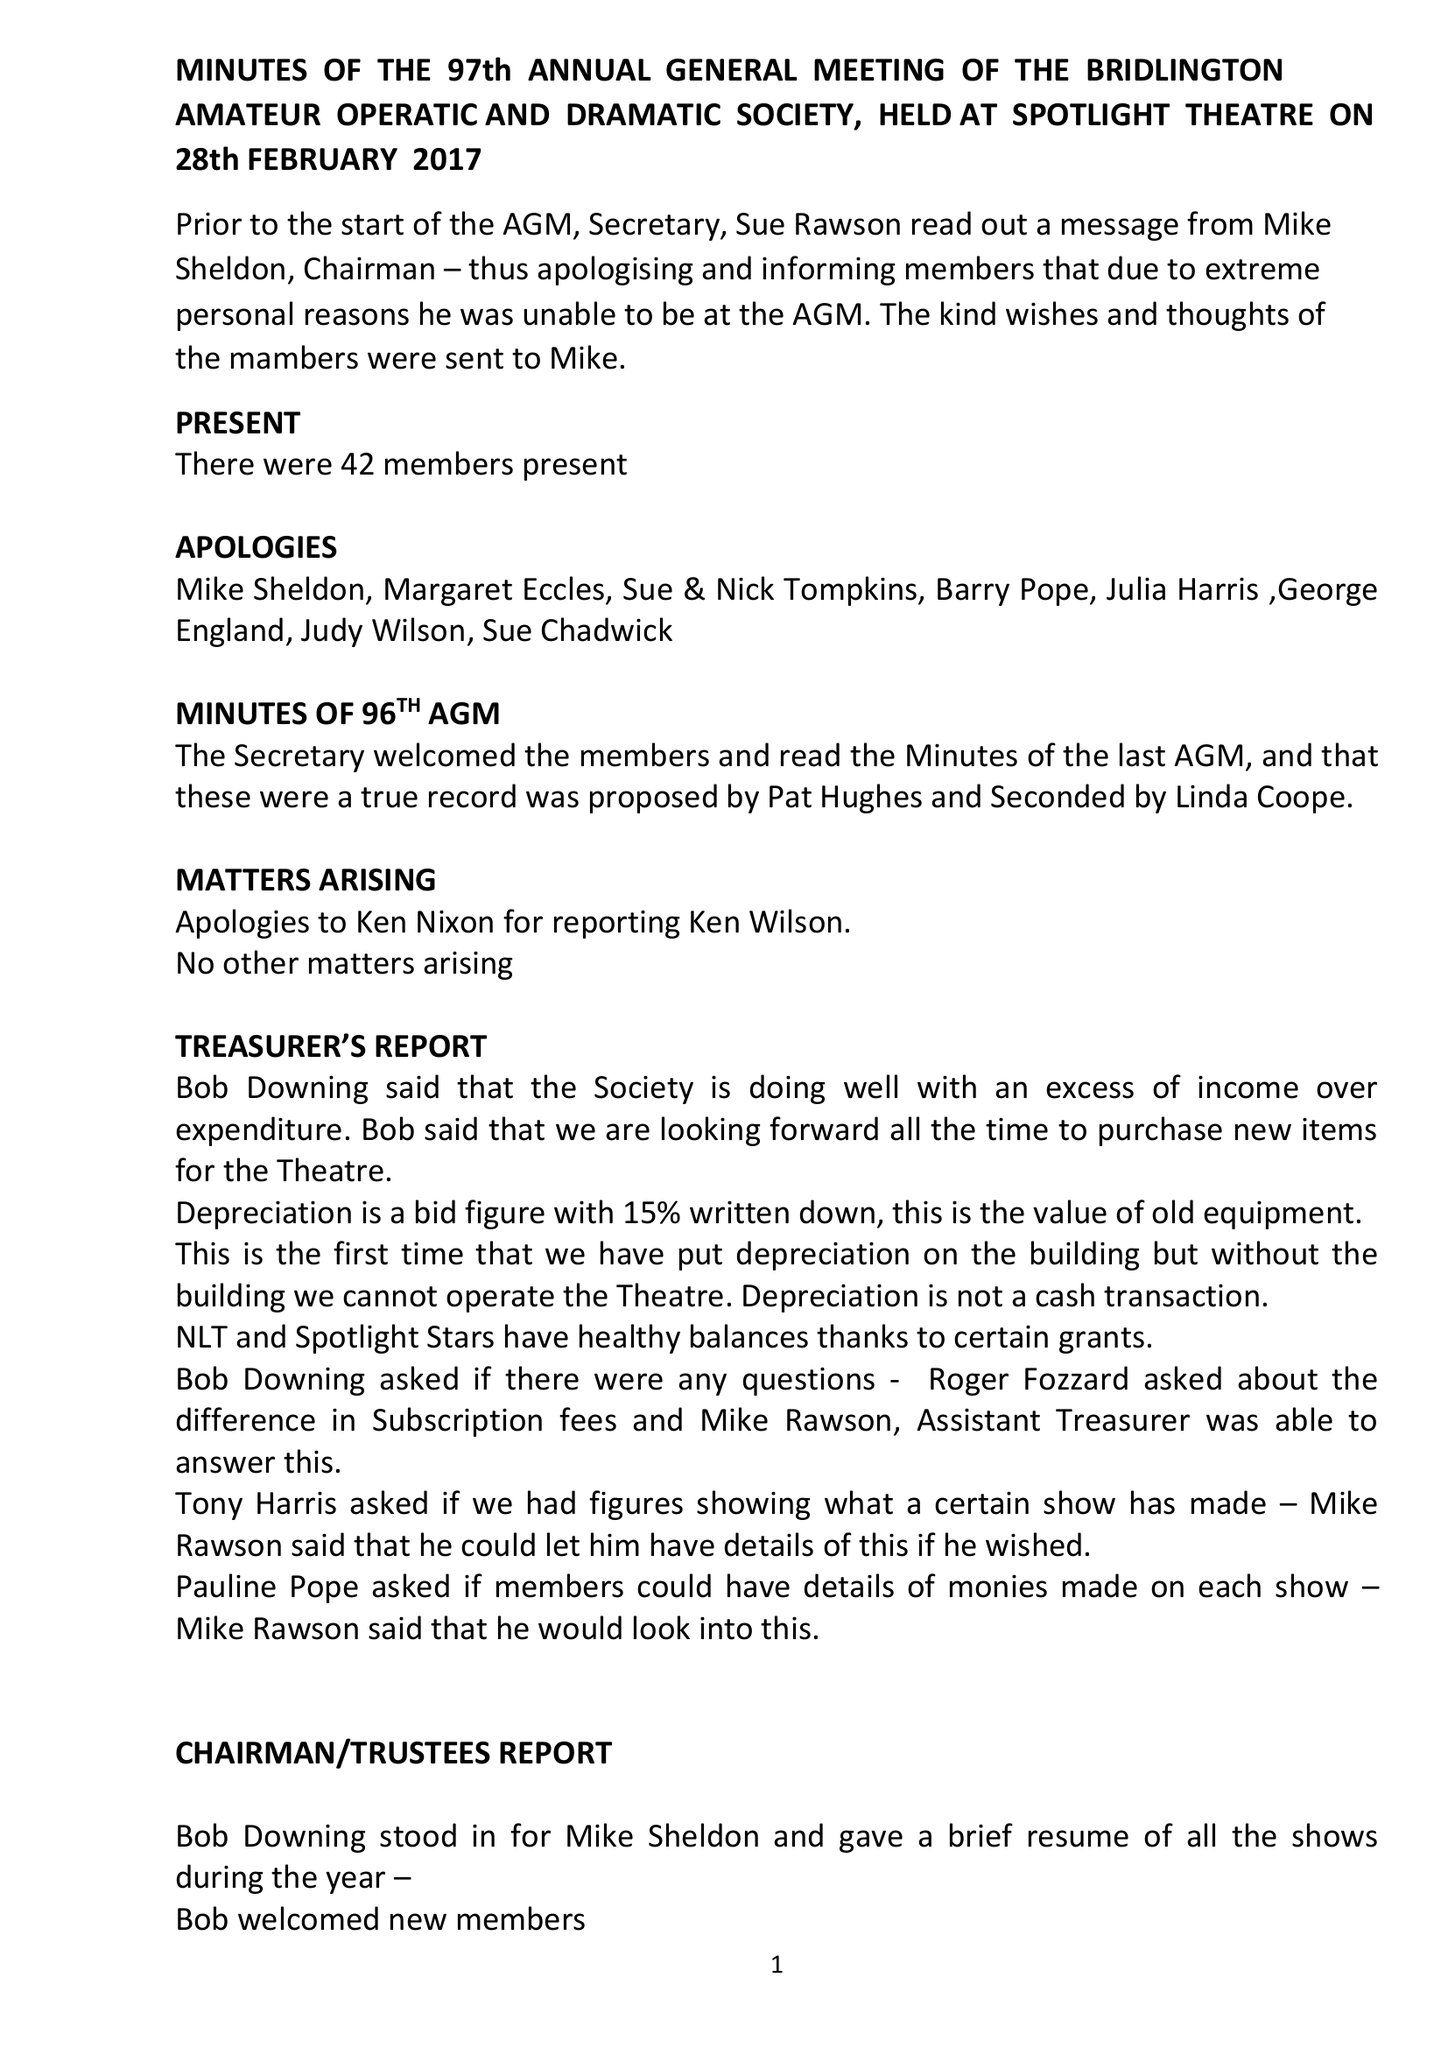What is the value for the address__street_line?
Answer the question using a single word or phrase. None 